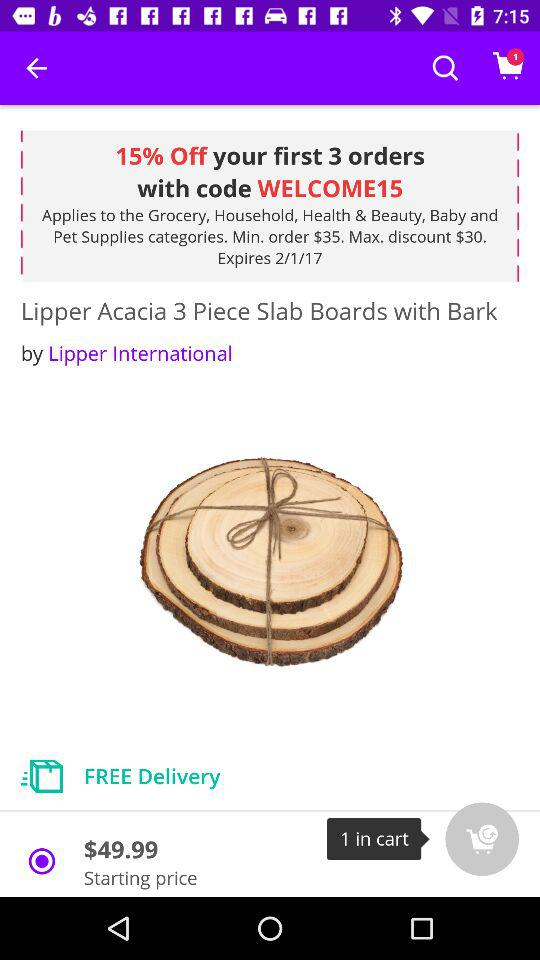How much is the discount?
Answer the question using a single word or phrase. 15% 